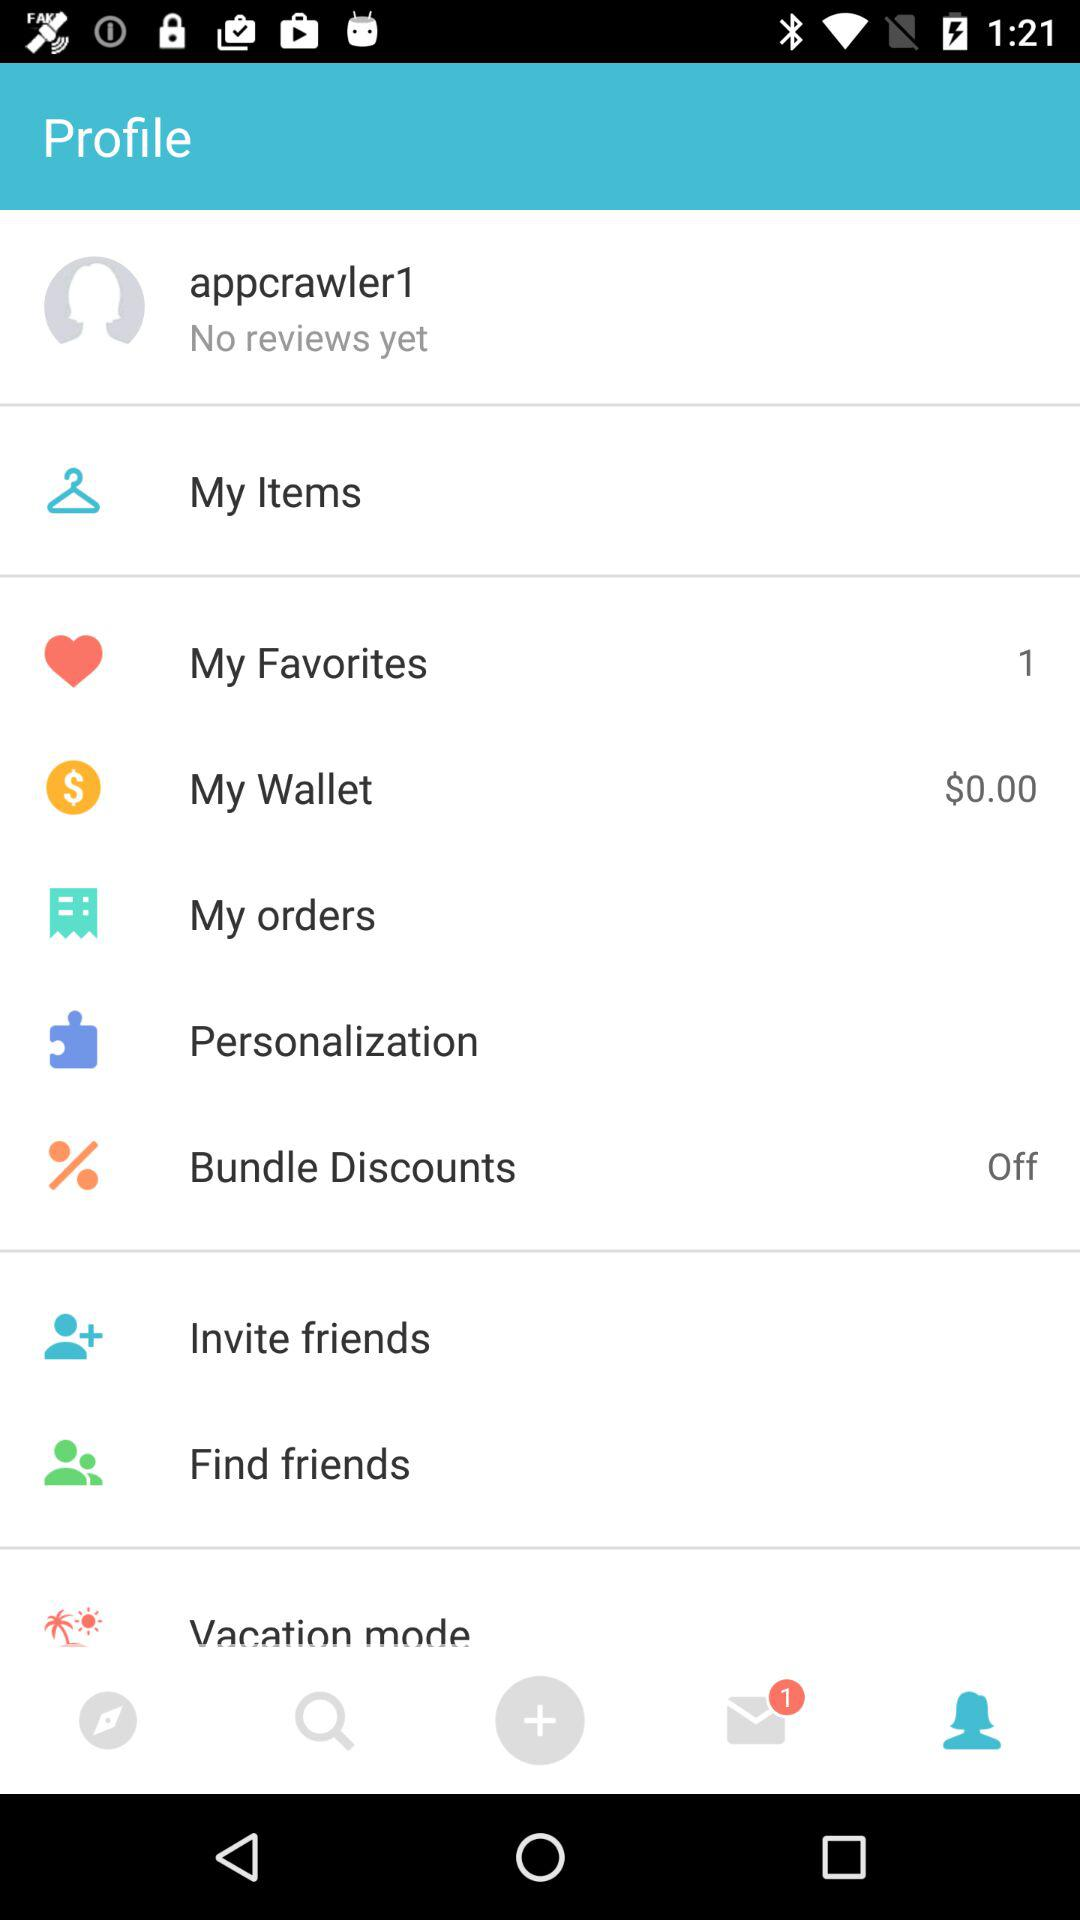What is the username? The username is "appcrawler1". 